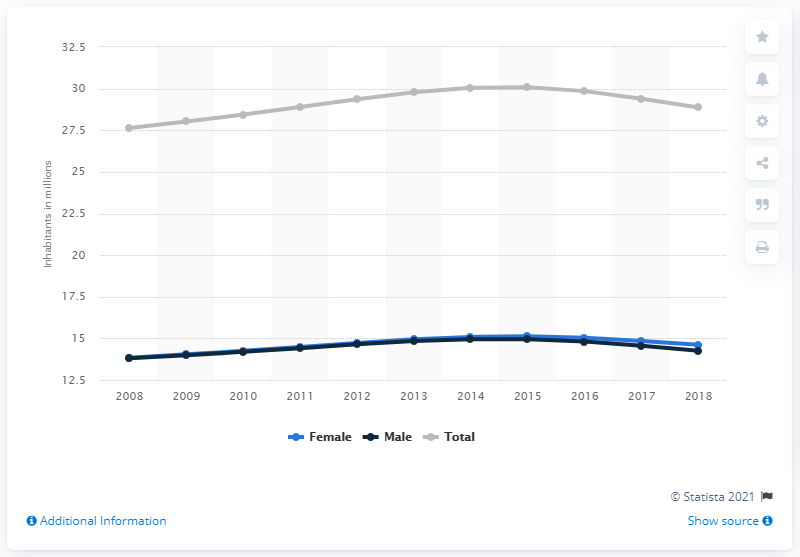Point out several critical features in this image. In 2015, the population of Venezuela declined. In 2018, it is estimated that 14.25 million men lived in Venezuela. In 2018, an estimated 28.87 people lived in Venezuela. 